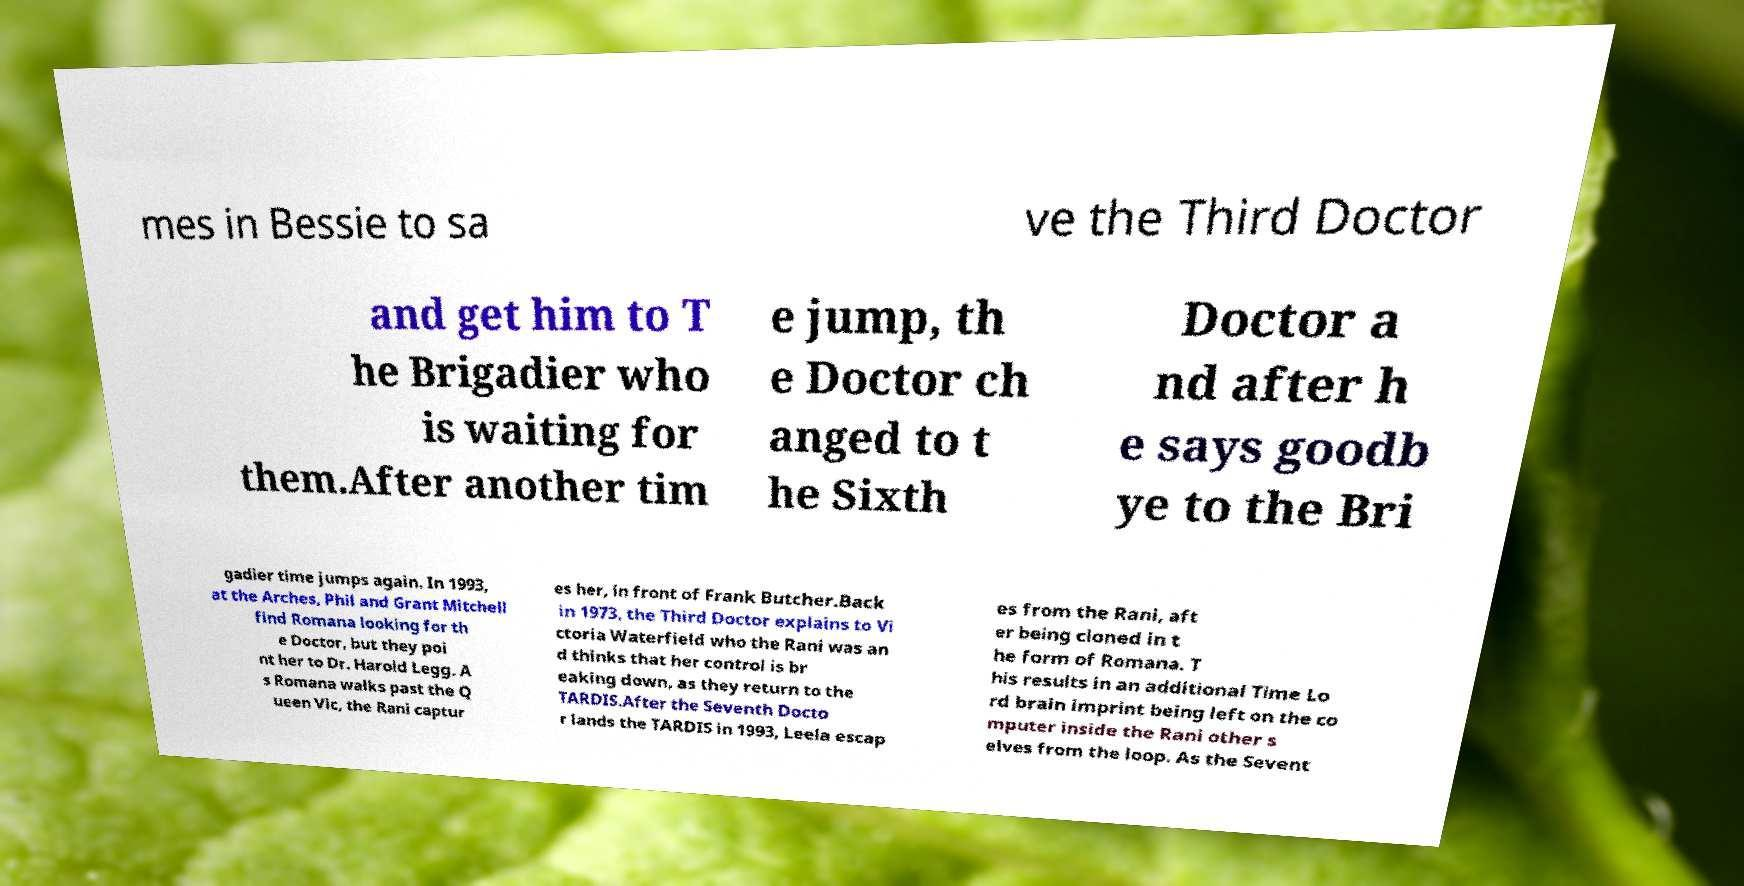Could you extract and type out the text from this image? mes in Bessie to sa ve the Third Doctor and get him to T he Brigadier who is waiting for them.After another tim e jump, th e Doctor ch anged to t he Sixth Doctor a nd after h e says goodb ye to the Bri gadier time jumps again. In 1993, at the Arches, Phil and Grant Mitchell find Romana looking for th e Doctor, but they poi nt her to Dr. Harold Legg. A s Romana walks past the Q ueen Vic, the Rani captur es her, in front of Frank Butcher.Back in 1973, the Third Doctor explains to Vi ctoria Waterfield who the Rani was an d thinks that her control is br eaking down, as they return to the TARDIS.After the Seventh Docto r lands the TARDIS in 1993, Leela escap es from the Rani, aft er being cloned in t he form of Romana. T his results in an additional Time Lo rd brain imprint being left on the co mputer inside the Rani other s elves from the loop. As the Sevent 